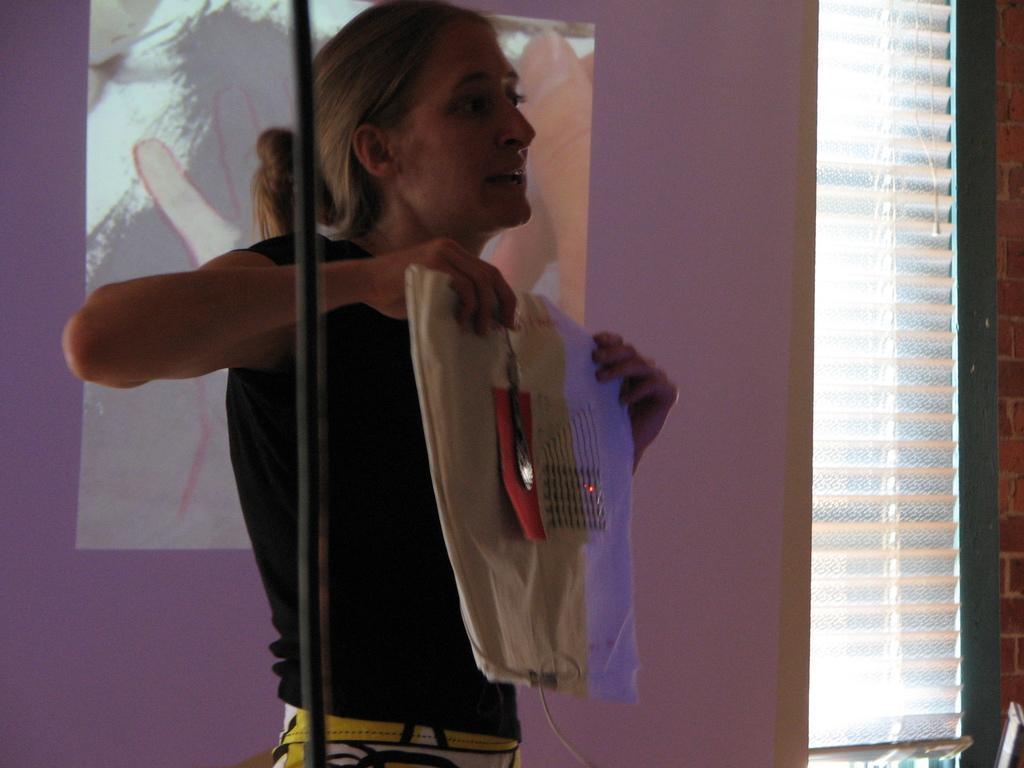How would you summarize this image in a sentence or two? In this image there is a window blind on the right corner. There is a person holding object, there is an object in the foreground. We can see depictions on the wall in the background. 